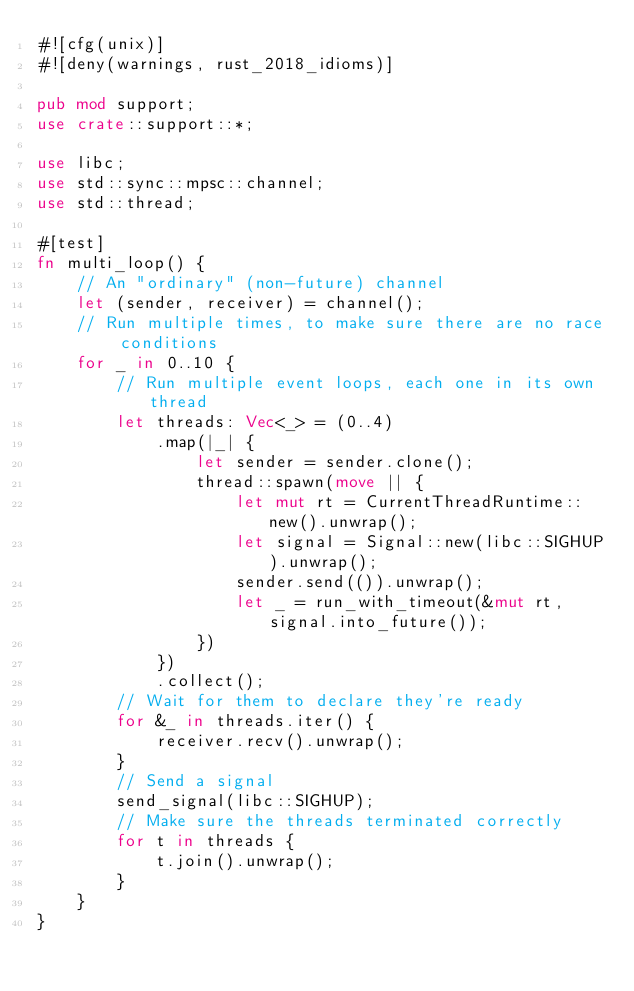Convert code to text. <code><loc_0><loc_0><loc_500><loc_500><_Rust_>#![cfg(unix)]
#![deny(warnings, rust_2018_idioms)]

pub mod support;
use crate::support::*;

use libc;
use std::sync::mpsc::channel;
use std::thread;

#[test]
fn multi_loop() {
    // An "ordinary" (non-future) channel
    let (sender, receiver) = channel();
    // Run multiple times, to make sure there are no race conditions
    for _ in 0..10 {
        // Run multiple event loops, each one in its own thread
        let threads: Vec<_> = (0..4)
            .map(|_| {
                let sender = sender.clone();
                thread::spawn(move || {
                    let mut rt = CurrentThreadRuntime::new().unwrap();
                    let signal = Signal::new(libc::SIGHUP).unwrap();
                    sender.send(()).unwrap();
                    let _ = run_with_timeout(&mut rt, signal.into_future());
                })
            })
            .collect();
        // Wait for them to declare they're ready
        for &_ in threads.iter() {
            receiver.recv().unwrap();
        }
        // Send a signal
        send_signal(libc::SIGHUP);
        // Make sure the threads terminated correctly
        for t in threads {
            t.join().unwrap();
        }
    }
}
</code> 